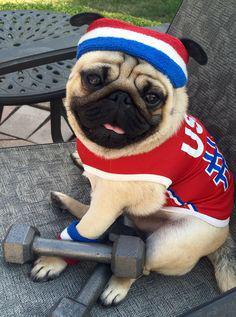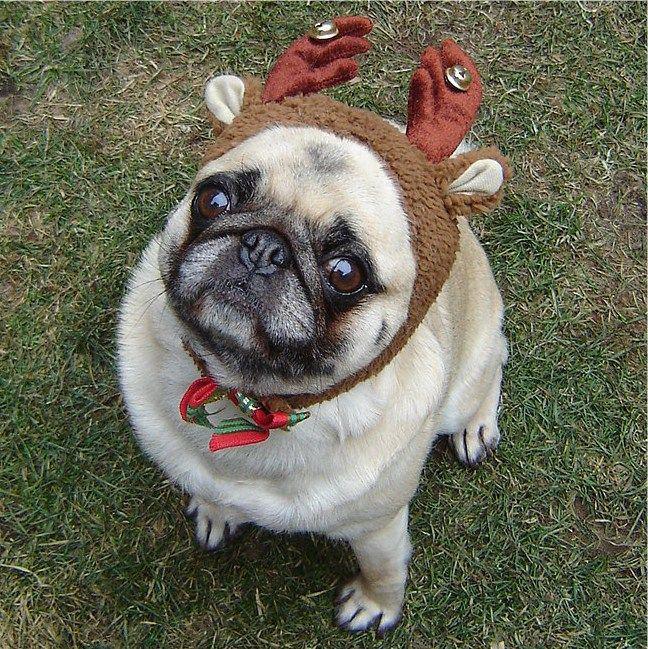The first image is the image on the left, the second image is the image on the right. For the images displayed, is the sentence "Some dogs are riding a carnival ride." factually correct? Answer yes or no. No. The first image is the image on the left, the second image is the image on the right. Given the left and right images, does the statement "Three beige pugs with dark muzzles are sitting in a row inside a red and blue car, and the middle dog has one paw on the steering wheel." hold true? Answer yes or no. No. 